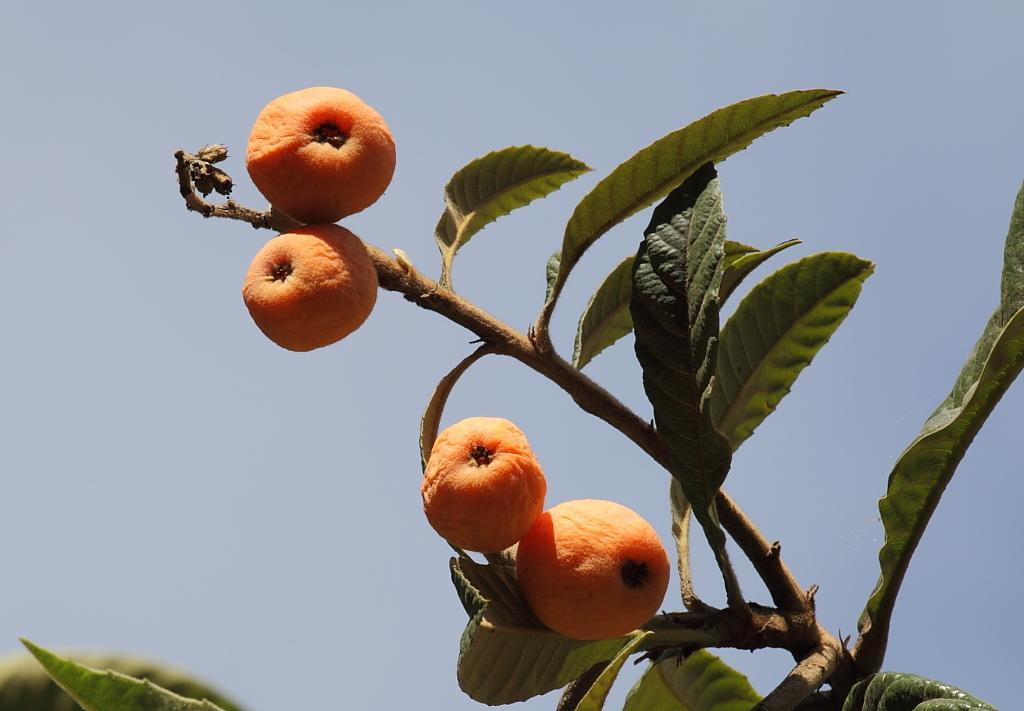Please provide a concise description of this image. In the picture I can see a tree which has fruits. In the background I can see the sky. 